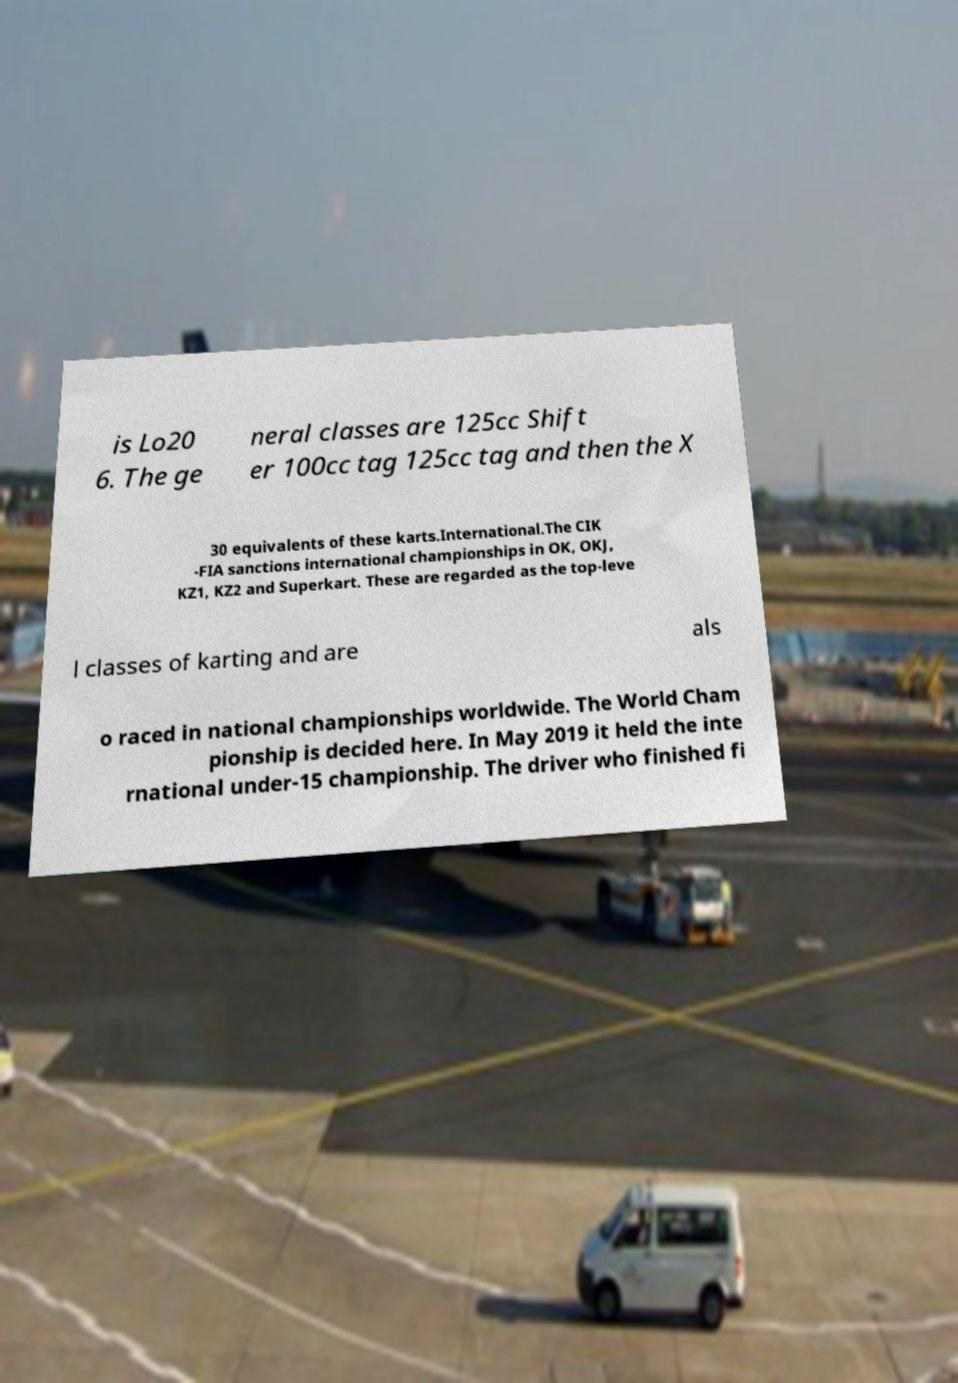Can you read and provide the text displayed in the image?This photo seems to have some interesting text. Can you extract and type it out for me? is Lo20 6. The ge neral classes are 125cc Shift er 100cc tag 125cc tag and then the X 30 equivalents of these karts.International.The CIK -FIA sanctions international championships in OK, OKJ, KZ1, KZ2 and Superkart. These are regarded as the top-leve l classes of karting and are als o raced in national championships worldwide. The World Cham pionship is decided here. In May 2019 it held the inte rnational under-15 championship. The driver who finished fi 